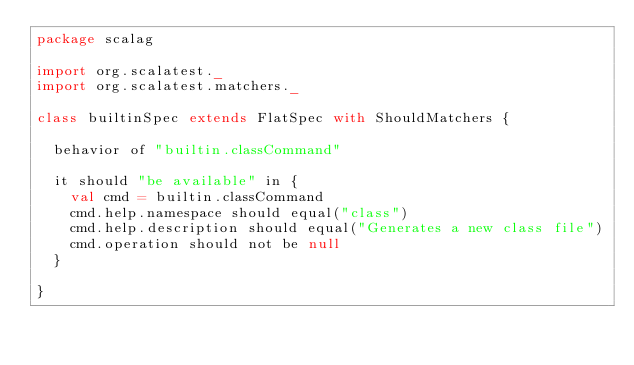<code> <loc_0><loc_0><loc_500><loc_500><_Scala_>package scalag

import org.scalatest._
import org.scalatest.matchers._

class builtinSpec extends FlatSpec with ShouldMatchers {

  behavior of "builtin.classCommand"

  it should "be available" in {
    val cmd = builtin.classCommand
    cmd.help.namespace should equal("class")
    cmd.help.description should equal("Generates a new class file")
    cmd.operation should not be null
  }

}
</code> 